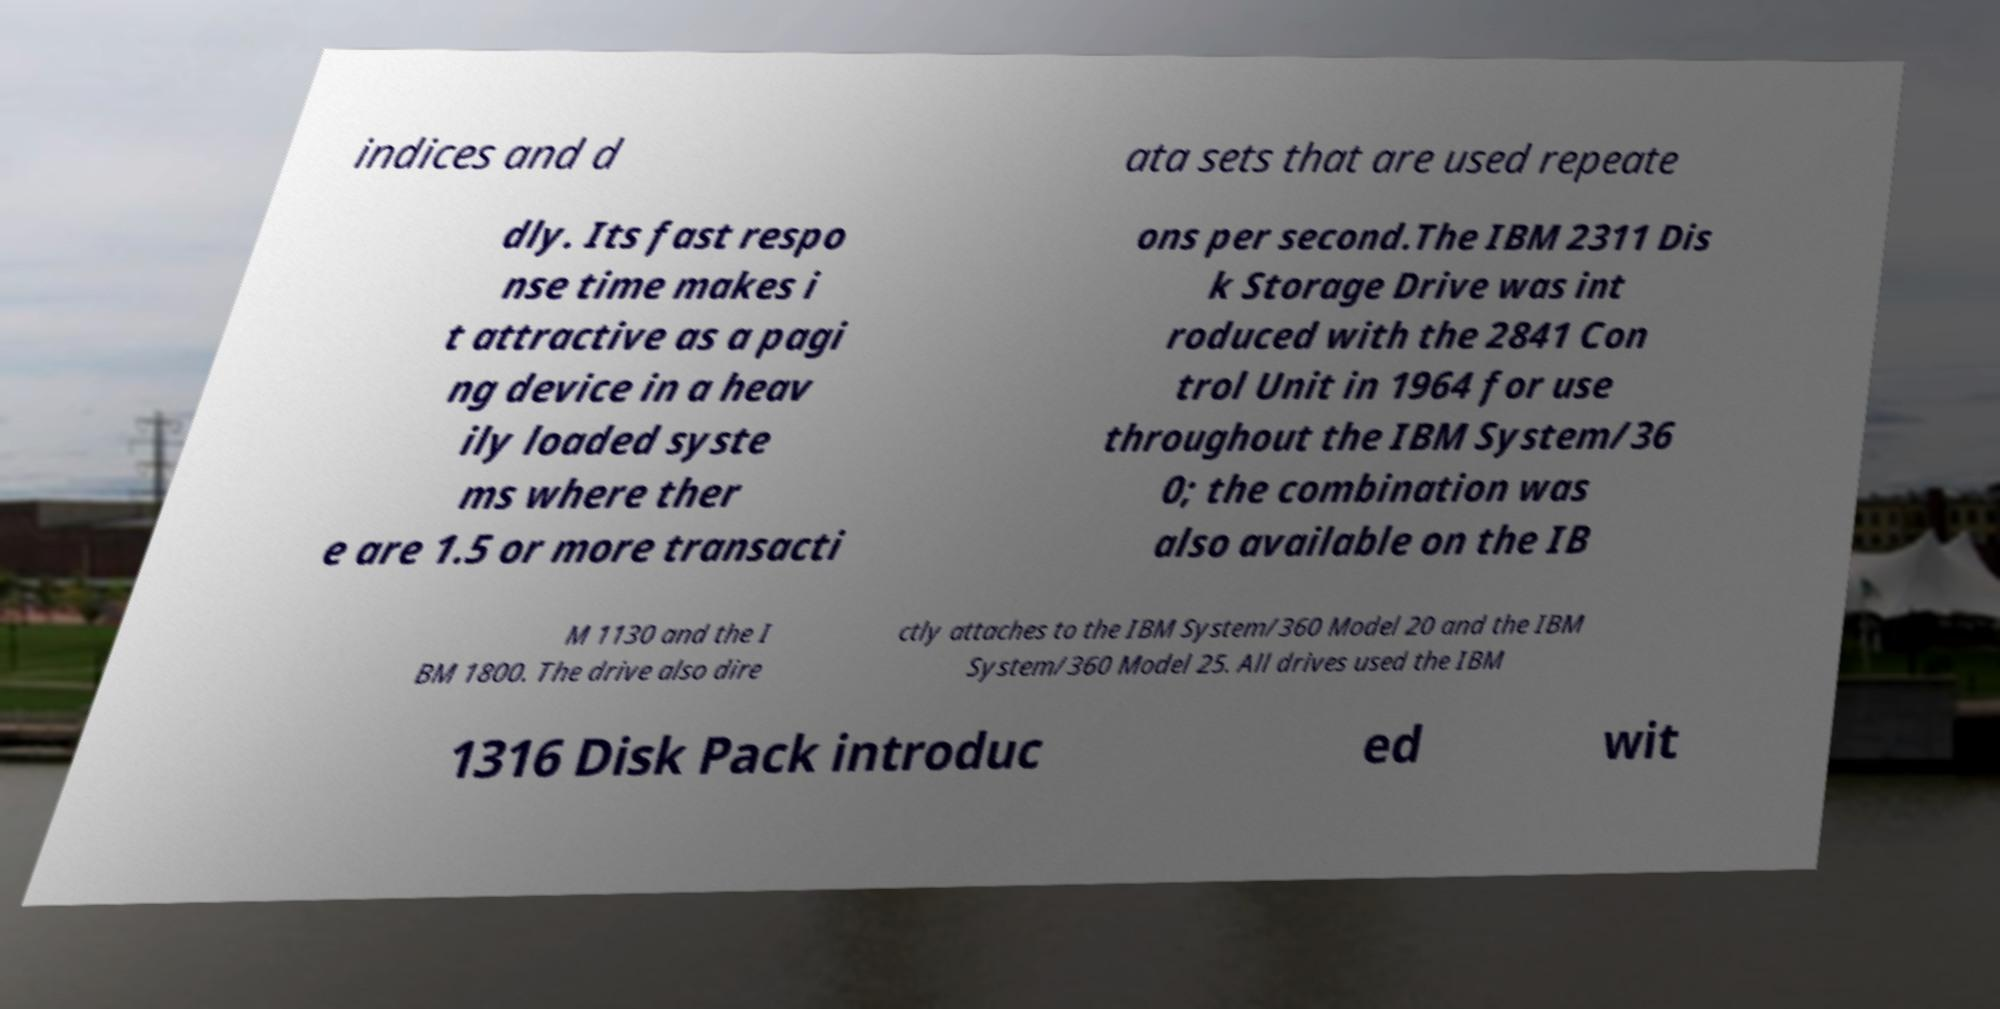What messages or text are displayed in this image? I need them in a readable, typed format. indices and d ata sets that are used repeate dly. Its fast respo nse time makes i t attractive as a pagi ng device in a heav ily loaded syste ms where ther e are 1.5 or more transacti ons per second.The IBM 2311 Dis k Storage Drive was int roduced with the 2841 Con trol Unit in 1964 for use throughout the IBM System/36 0; the combination was also available on the IB M 1130 and the I BM 1800. The drive also dire ctly attaches to the IBM System/360 Model 20 and the IBM System/360 Model 25. All drives used the IBM 1316 Disk Pack introduc ed wit 